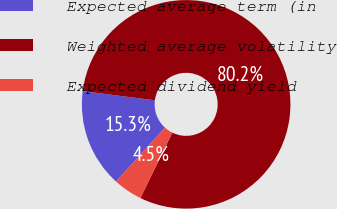Convert chart. <chart><loc_0><loc_0><loc_500><loc_500><pie_chart><fcel>Expected average term (in<fcel>Weighted average volatility<fcel>Expected dividend yield<nl><fcel>15.29%<fcel>80.2%<fcel>4.51%<nl></chart> 